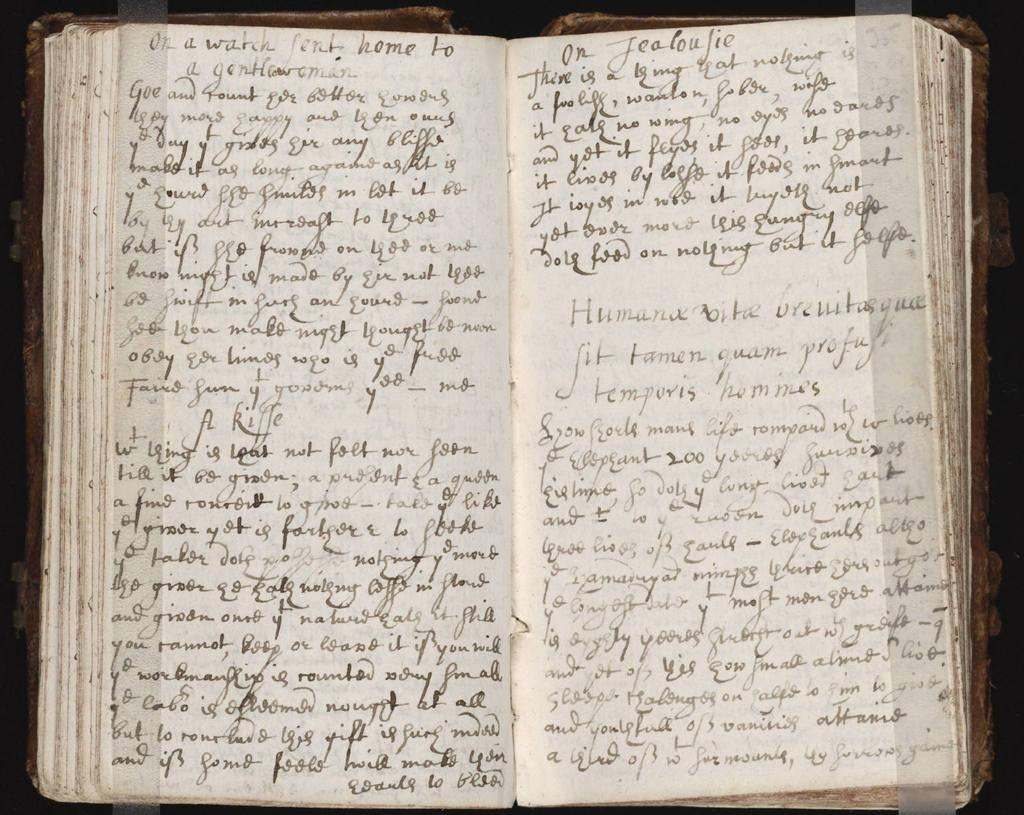<image>
Summarize the visual content of the image. An open handwritten book starts with the words or a watch. 